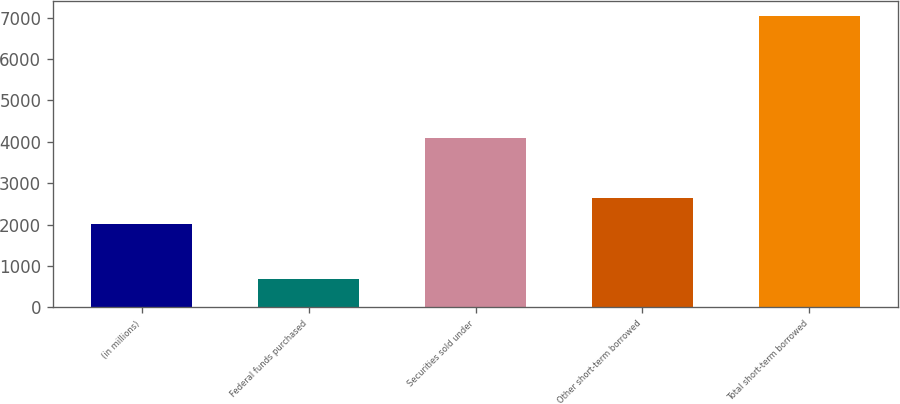<chart> <loc_0><loc_0><loc_500><loc_500><bar_chart><fcel>(in millions)<fcel>Federal funds purchased<fcel>Securities sold under<fcel>Other short-term borrowed<fcel>Total short-term borrowed<nl><fcel>2013<fcel>689<fcel>4102<fcel>2648.3<fcel>7042<nl></chart> 